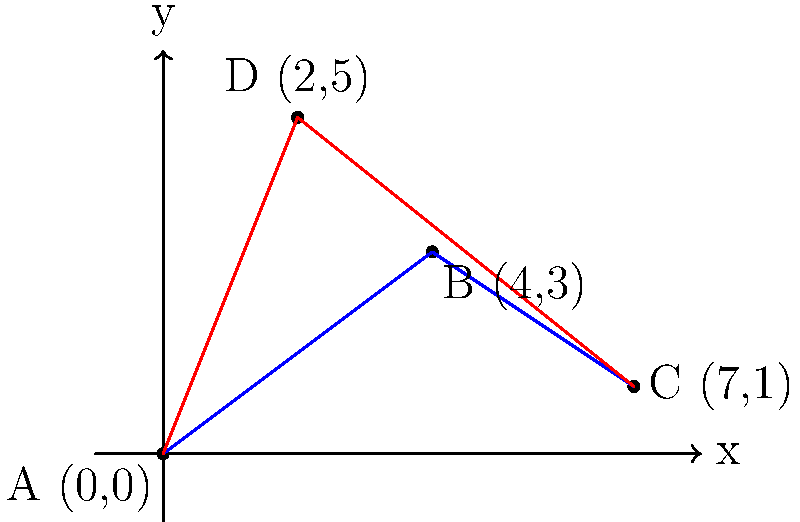As a bookings agent, you're planning a route for a speaker attending seminars in four cities. The cities' locations are represented on a coordinate plane: A(0,0), B(4,3), C(7,1), and D(2,5). The speaker starts at city A and must end at city C. Which route minimizes the total distance traveled: A-B-C (blue) or A-D-C (red)? Calculate the difference in distance between these two routes. To solve this problem, we need to calculate the distances for both routes and compare them:

1. Calculate the distance of route A-B-C (blue):
   Distance AB = $\sqrt{(4-0)^2 + (3-0)^2} = \sqrt{16 + 9} = 5$
   Distance BC = $\sqrt{(7-4)^2 + (1-3)^2} = \sqrt{9 + 4} = \sqrt{13}$
   Total distance A-B-C = $5 + \sqrt{13}$

2. Calculate the distance of route A-D-C (red):
   Distance AD = $\sqrt{(2-0)^2 + (5-0)^2} = \sqrt{4 + 25} = \sqrt{29}$
   Distance DC = $\sqrt{(7-2)^2 + (1-5)^2} = \sqrt{25 + 16} = \sqrt{41}$
   Total distance A-D-C = $\sqrt{29} + \sqrt{41}$

3. Calculate the difference between the two routes:
   Difference = $(5 + \sqrt{13}) - (\sqrt{29} + \sqrt{41})$
   
4. Simplify:
   $5 + \sqrt{13} - \sqrt{29} - \sqrt{41} \approx -0.6349$

The negative result indicates that the A-B-C route (blue) is shorter than the A-D-C route (red) by approximately 0.6349 units.
Answer: A-B-C route; $\approx 0.6349$ units shorter 